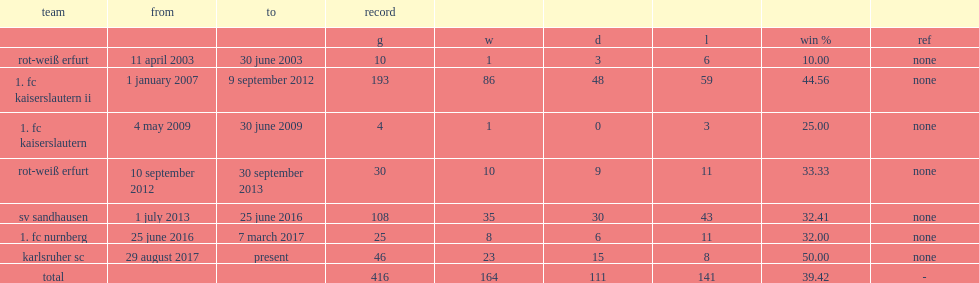How many games did schwartz, the manager of rot-weiß erfurt between 11 april 2003 and 30 june 2003, won out of 10 matches? 1.0. 